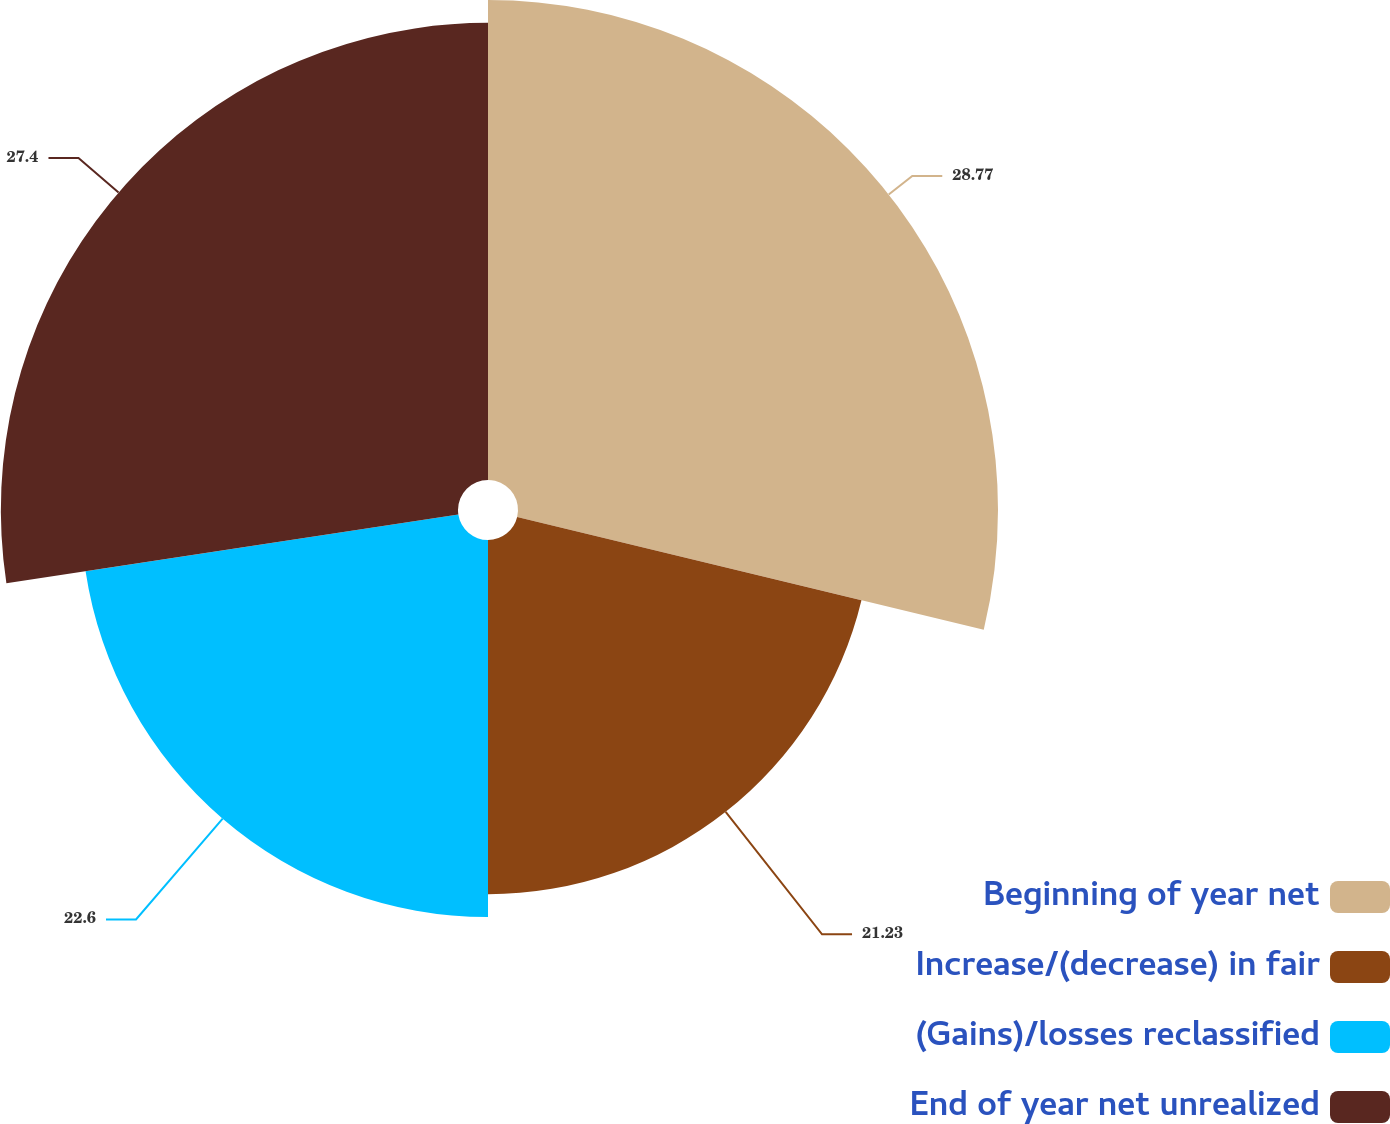Convert chart. <chart><loc_0><loc_0><loc_500><loc_500><pie_chart><fcel>Beginning of year net<fcel>Increase/(decrease) in fair<fcel>(Gains)/losses reclassified<fcel>End of year net unrealized<nl><fcel>28.77%<fcel>21.23%<fcel>22.6%<fcel>27.4%<nl></chart> 